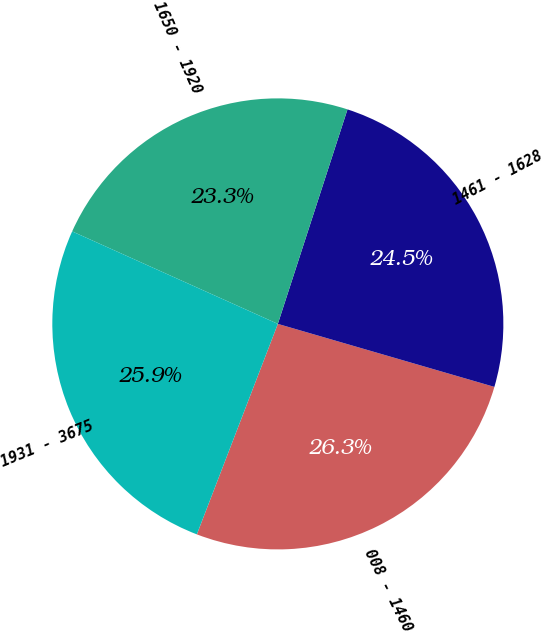<chart> <loc_0><loc_0><loc_500><loc_500><pie_chart><fcel>008 - 1460<fcel>1461 - 1628<fcel>1650 - 1920<fcel>1931 - 3675<nl><fcel>26.34%<fcel>24.51%<fcel>23.27%<fcel>25.88%<nl></chart> 